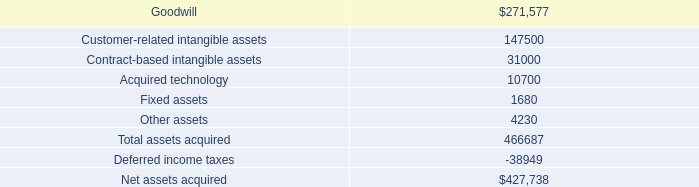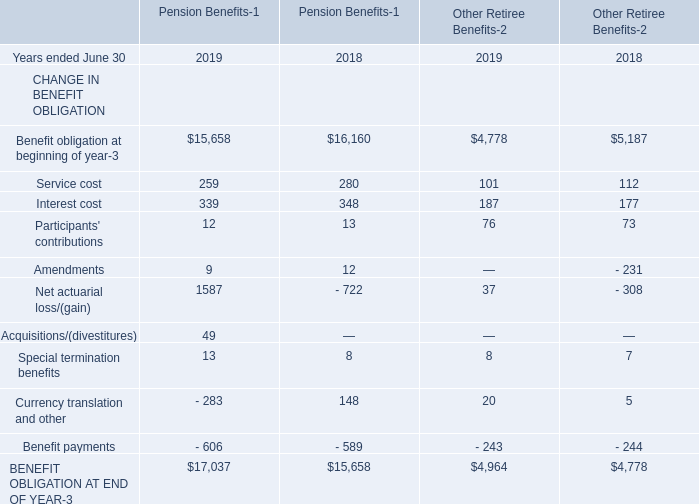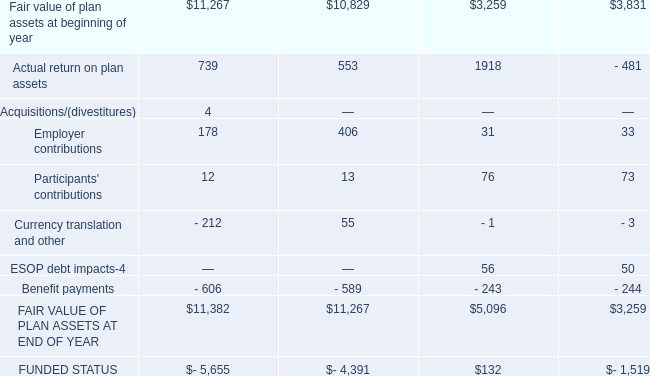what's the total amount of BENEFIT OBLIGATION AT END OF YEAR of Pension Benefits 2018, Fair value of plan assets at beginning of year, and FUNDED STATUS is ? 
Computations: ((15658.0 + 3259.0) + 1519.0)
Answer: 20436.0. 